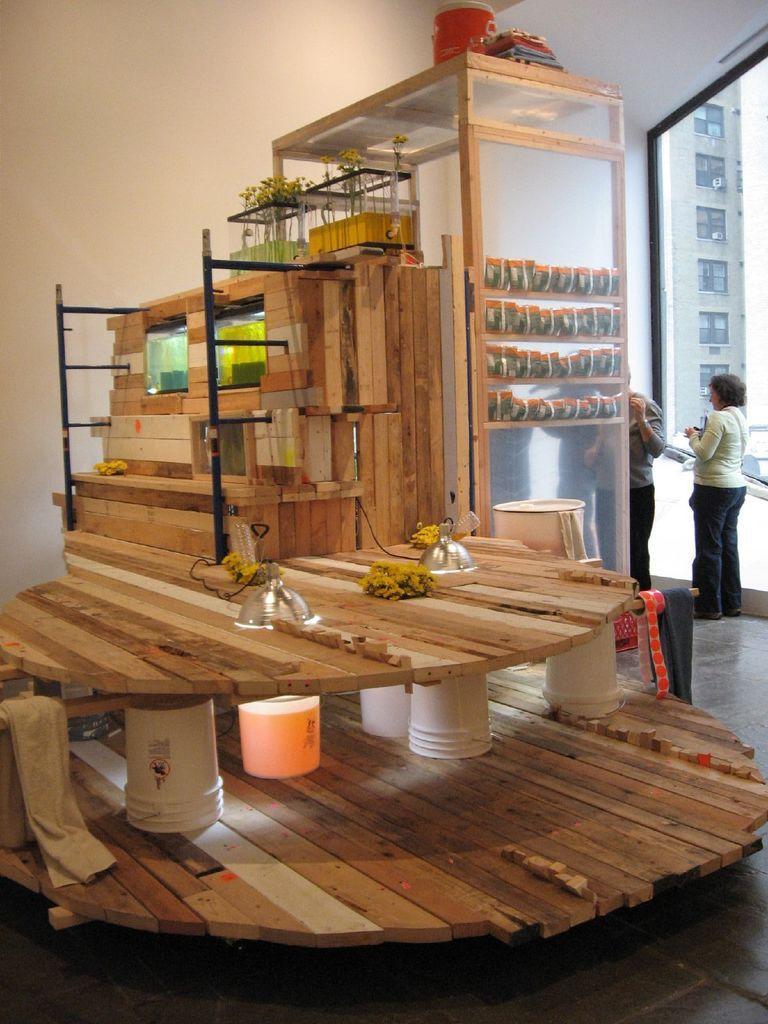Please provide a concise description of this image. This Picture describe about the big wooden rafter placed on each other on the top of the buckets and some iron pipes attached to them. On the top we can see the wooden basket and a big glass box in which some packets are seen. Behind we can see the a woman wearing white jacket standing and discussing with the man beside her and a big glass window in the background. 